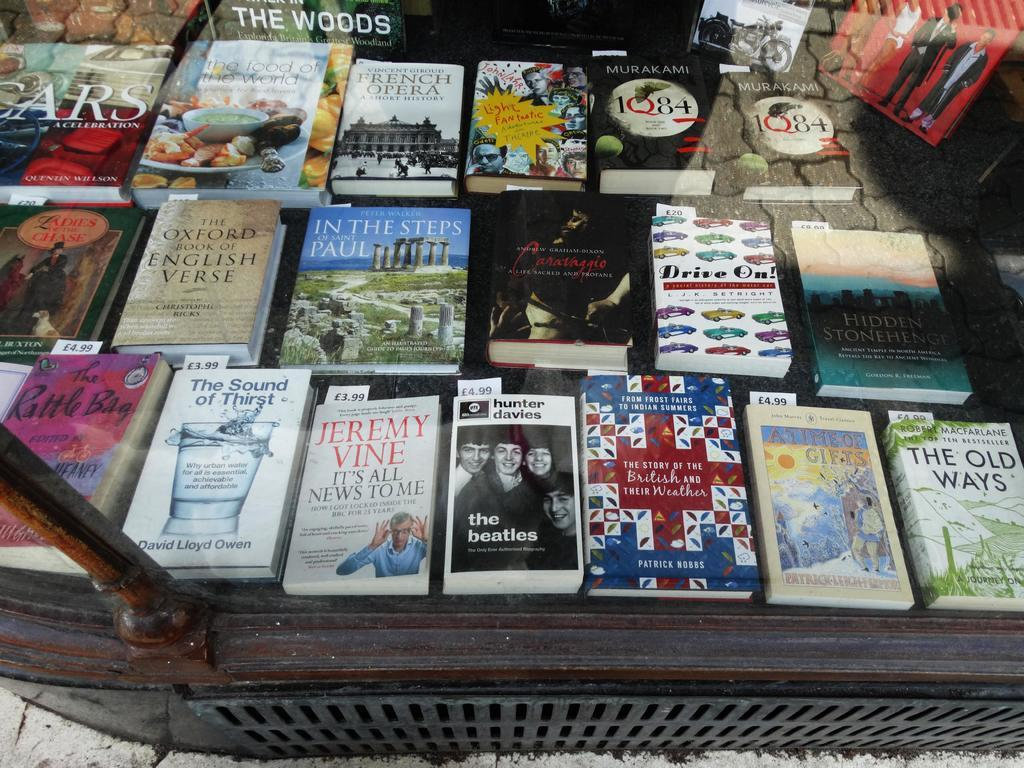<image>
Summarize the visual content of the image. A book by Jeremy Vine sits on a table with several other books. 